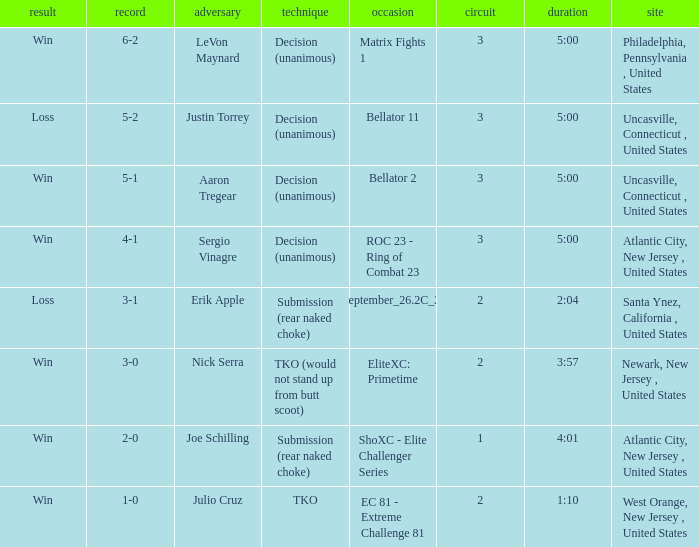Who was the opponent when there was a TKO method? Julio Cruz. 